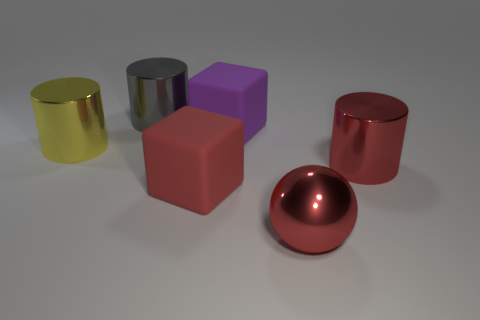The metallic object that is the same color as the ball is what shape?
Your response must be concise. Cylinder. How many things are red shiny objects in front of the red shiny cylinder or large cylinders on the left side of the purple matte object?
Your answer should be very brief. 3. There is a large ball to the right of the red cube; does it have the same color as the large cylinder that is to the right of the gray metal thing?
Offer a very short reply. Yes. What is the shape of the big red object that is to the left of the red cylinder and behind the large red metallic sphere?
Make the answer very short. Cube. What is the color of the other block that is the same size as the red cube?
Ensure brevity in your answer.  Purple. Are there any metallic cylinders that have the same color as the sphere?
Offer a very short reply. Yes. Is the size of the cylinder to the right of the purple rubber block the same as the cube behind the yellow shiny cylinder?
Give a very brief answer. Yes. What is the object that is both in front of the yellow cylinder and behind the big red cube made of?
Provide a short and direct response. Metal. The cylinder that is the same color as the metallic sphere is what size?
Keep it short and to the point. Large. How many other things are the same size as the red metal sphere?
Offer a very short reply. 5. 